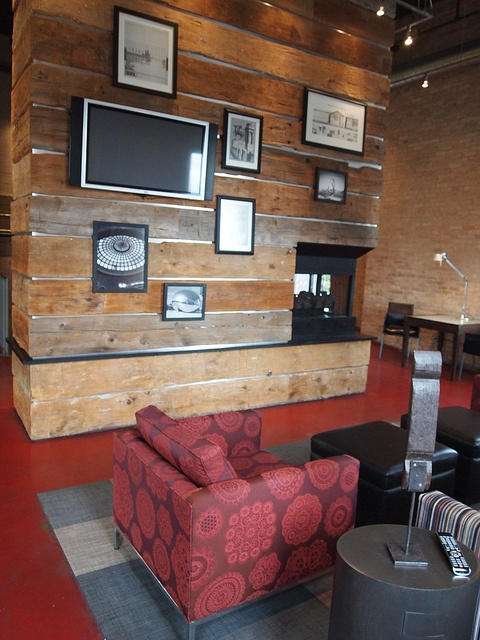Describe the objects in this image and their specific colors. I can see chair in black, brown, and maroon tones, couch in black, brown, and maroon tones, tv in black, gray, darkblue, and white tones, couch in black, gray, and darkgray tones, and dining table in black, tan, and gray tones in this image. 